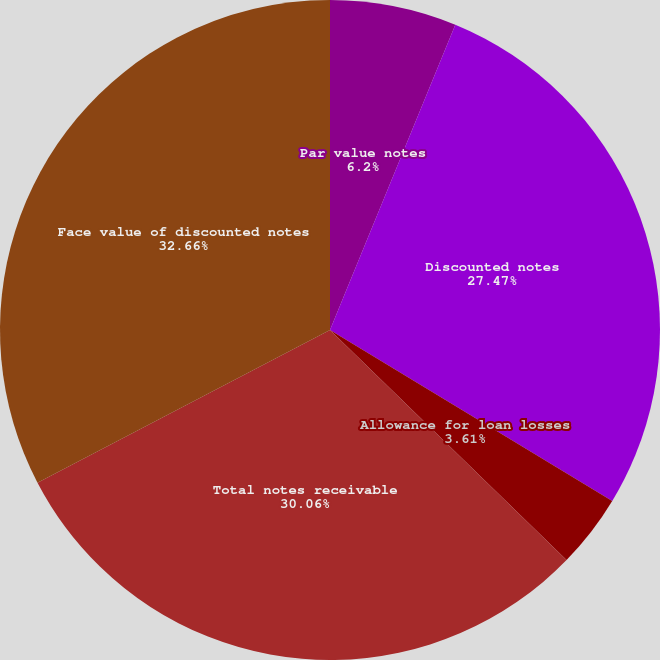Convert chart. <chart><loc_0><loc_0><loc_500><loc_500><pie_chart><fcel>Par value notes<fcel>Discounted notes<fcel>Allowance for loan losses<fcel>Total notes receivable<fcel>Face value of discounted notes<nl><fcel>6.2%<fcel>27.47%<fcel>3.61%<fcel>30.06%<fcel>32.66%<nl></chart> 